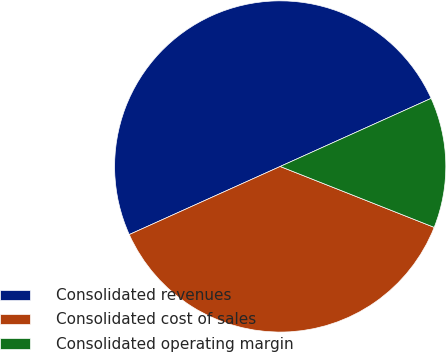Convert chart. <chart><loc_0><loc_0><loc_500><loc_500><pie_chart><fcel>Consolidated revenues<fcel>Consolidated cost of sales<fcel>Consolidated operating margin<nl><fcel>50.0%<fcel>37.26%<fcel>12.74%<nl></chart> 